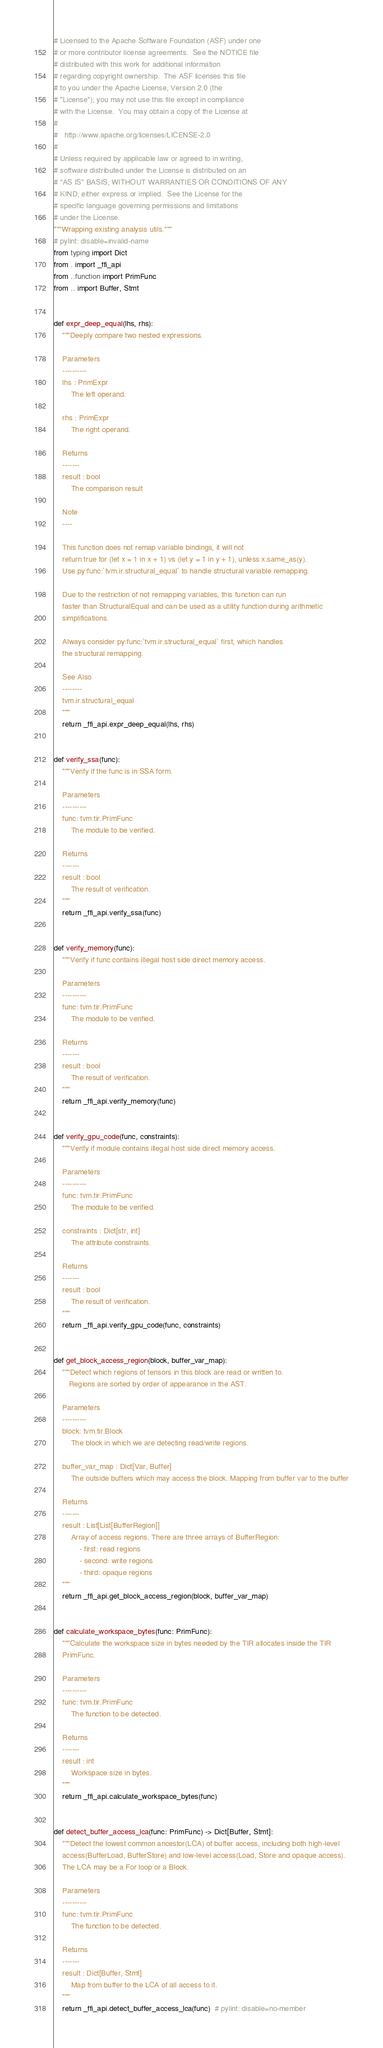<code> <loc_0><loc_0><loc_500><loc_500><_Python_># Licensed to the Apache Software Foundation (ASF) under one
# or more contributor license agreements.  See the NOTICE file
# distributed with this work for additional information
# regarding copyright ownership.  The ASF licenses this file
# to you under the Apache License, Version 2.0 (the
# "License"); you may not use this file except in compliance
# with the License.  You may obtain a copy of the License at
#
#   http://www.apache.org/licenses/LICENSE-2.0
#
# Unless required by applicable law or agreed to in writing,
# software distributed under the License is distributed on an
# "AS IS" BASIS, WITHOUT WARRANTIES OR CONDITIONS OF ANY
# KIND, either express or implied.  See the License for the
# specific language governing permissions and limitations
# under the License.
"""Wrapping existing analysis utils."""
# pylint: disable=invalid-name
from typing import Dict
from . import _ffi_api
from ..function import PrimFunc
from .. import Buffer, Stmt


def expr_deep_equal(lhs, rhs):
    """Deeply compare two nested expressions.

    Parameters
    ----------
    lhs : PrimExpr
        The left operand.

    rhs : PrimExpr
        The right operand.

    Returns
    -------
    result : bool
        The comparison result

    Note
    ----

    This function does not remap variable bindings, it will not
    return true for (let x = 1 in x + 1) vs (let y = 1 in y + 1), unless x.same_as(y).
    Use py:func:`tvm.ir.structural_equal` to handle structural variable remapping.

    Due to the restriction of not remapping variables, this function can run
    faster than StructuralEqual and can be used as a utility function during arithmetic
    simplifications.

    Always consider py:func:`tvm.ir.structural_equal` first, which handles
    the structural remapping.

    See Also
    --------
    tvm.ir.structural_equal
    """
    return _ffi_api.expr_deep_equal(lhs, rhs)


def verify_ssa(func):
    """Verify if the func is in SSA form.

    Parameters
    ----------
    func: tvm.tir.PrimFunc
        The module to be verified.

    Returns
    -------
    result : bool
        The result of verification.
    """
    return _ffi_api.verify_ssa(func)


def verify_memory(func):
    """Verify if func contains illegal host side direct memory access.

    Parameters
    ----------
    func: tvm.tir.PrimFunc
        The module to be verified.

    Returns
    -------
    result : bool
        The result of verification.
    """
    return _ffi_api.verify_memory(func)


def verify_gpu_code(func, constraints):
    """Verify if module contains illegal host side direct memory access.

    Parameters
    ----------
    func: tvm.tir.PrimFunc
        The module to be verified.

    constraints : Dict[str, int]
        The attribute constraints.

    Returns
    -------
    result : bool
        The result of verification.
    """
    return _ffi_api.verify_gpu_code(func, constraints)


def get_block_access_region(block, buffer_var_map):
    """Detect which regions of tensors in this block are read or written to.
       Regions are sorted by order of appearance in the AST.

    Parameters
    ----------
    block: tvm.tir.Block
        The block in which we are detecting read/write regions.

    buffer_var_map : Dict[Var, Buffer]
        The outside buffers which may access the block. Mapping from buffer var to the buffer

    Returns
    -------
    result : List[List[BufferRegion]]
        Array of access regions. There are three arrays of BufferRegion:
            - first: read regions
            - second: write regions
            - third: opaque regions
    """
    return _ffi_api.get_block_access_region(block, buffer_var_map)


def calculate_workspace_bytes(func: PrimFunc):
    """Calculate the workspace size in bytes needed by the TIR allocates inside the TIR
    PrimFunc.

    Parameters
    ----------
    func: tvm.tir.PrimFunc
        The function to be detected.

    Returns
    -------
    result : int
        Workspace size in bytes.
    """
    return _ffi_api.calculate_workspace_bytes(func)


def detect_buffer_access_lca(func: PrimFunc) -> Dict[Buffer, Stmt]:
    """Detect the lowest common ancestor(LCA) of buffer access, including both high-level
    access(BufferLoad, BufferStore) and low-level access(Load, Store and opaque access).
    The LCA may be a For loop or a Block.

    Parameters
    ----------
    func: tvm.tir.PrimFunc
        The function to be detected.

    Returns
    -------
    result : Dict[Buffer, Stmt]
        Map from buffer to the LCA of all access to it.
    """
    return _ffi_api.detect_buffer_access_lca(func)  # pylint: disable=no-member
</code> 